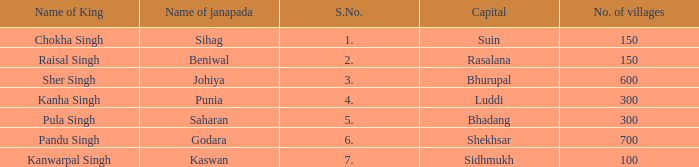What king has an S. number over 1 and a number of villages of 600? Sher Singh. Would you be able to parse every entry in this table? {'header': ['Name of King', 'Name of janapada', 'S.No.', 'Capital', 'No. of villages'], 'rows': [['Chokha Singh', 'Sihag', '1.', 'Suin', '150'], ['Raisal Singh', 'Beniwal', '2.', 'Rasalana', '150'], ['Sher Singh', 'Johiya', '3.', 'Bhurupal', '600'], ['Kanha Singh', 'Punia', '4.', 'Luddi', '300'], ['Pula Singh', 'Saharan', '5.', 'Bhadang', '300'], ['Pandu Singh', 'Godara', '6.', 'Shekhsar', '700'], ['Kanwarpal Singh', 'Kaswan', '7.', 'Sidhmukh', '100']]} 